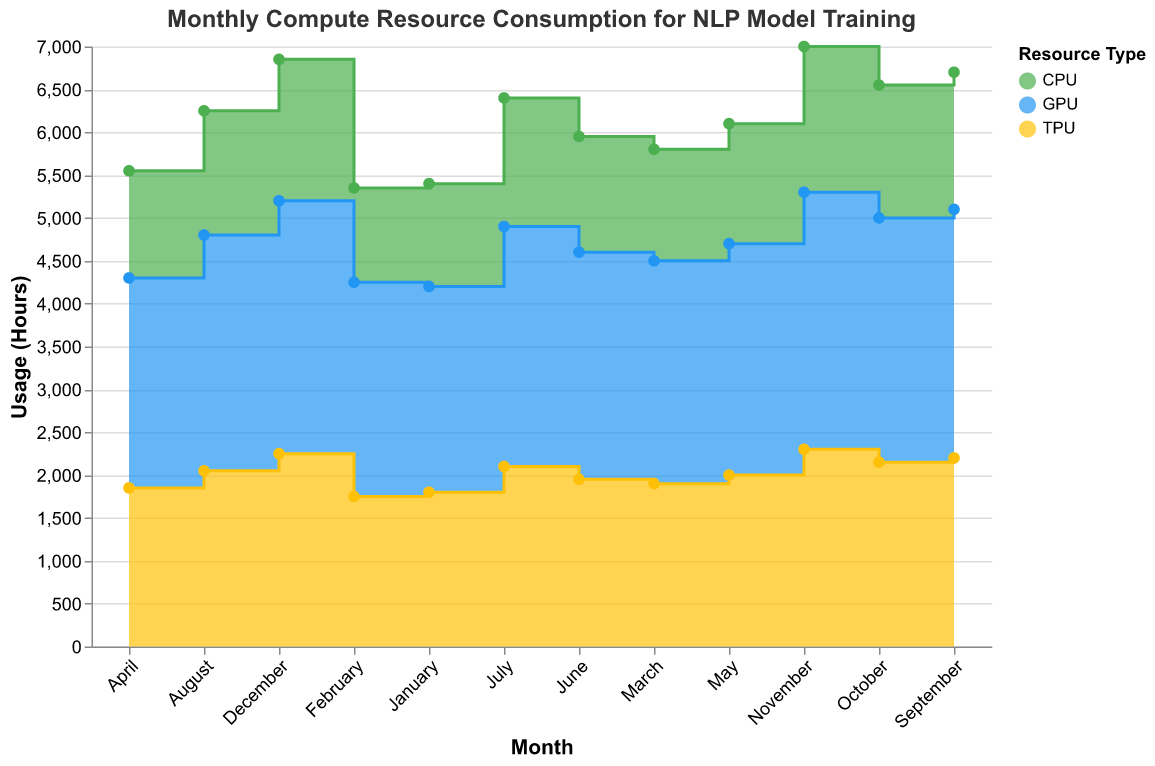What is the title of the chart? The title of the chart is displayed at the top and reads: "Monthly Compute Resource Consumption for NLP Model Training".
Answer: Monthly Compute Resource Consumption for NLP Model Training Which resource type had the highest usage in November? By looking at the November data points, GPU has the highest usage with 3000 hours.
Answer: GPU Which month had the highest total compute resource usage? To find the month with the highest total usage, sum the usage of CPU, GPU, and TPU for each month. November has the highest total compute resource usage: CPU (1700) + GPU (3000) + TPU (2300) = 7000 hours.
Answer: November How does the GPU usage in December compare to the GPU usage in January? GPU usage in December is 2950 hours, whereas GPU usage in January is 2400 hours. Comparing these, December has a higher GPU usage by 550 hours.
Answer: December has 550 hours more What is the average CPU usage over the 12 months? To find the average CPU usage, sum the CPU usage for each month and divide by 12: (1200 + 1100 + 1300 + 1250 + 1400 + 1350 + 1500 + 1450 + 1600 + 1550 + 1700 + 1650) / 12 = 15750 / 12 = 1312.5 hours.
Answer: 1312.5 hours Was there a month when both GPU and TPU usage decreased from the previous month? Compare month-to-month usage for GPU and TPU. From April to May, both GPU (2450 to 2700) and TPU (1850 to 2000) increased. From May to June, both GPU (2700 to 2650) and TPU (2000 to 1950) decreased. Hence, June is the month where both decreased from May.
Answer: June Which resource type showed more consistent monthly usage patterns throughout the year? Consistency can be observed by visually assessing the smoothness of the area chart lines. CPU usage shows relatively less fluctuation compared to GPU and TPU, indicating more consistent monthly usage.
Answer: CPU When did TPU usage surpass GPU usage? By tracking the lines in the step area chart, at no point throughout the year does TPU usage surpass GPU usage; GPU usage is consistently higher than TPU.
Answer: Never What is the combined usage (CPU + GPU + TPU) in July? Sum the CPU, GPU, and TPU usage in July: CPU (1500) + GPU (2800) + TPU (2100) = 6400 hours.
Answer: 6400 hours What is the trend of CPU usage from January to December? CPU usage starts at 1200 hours in January and increases generally over the months, with some minor fluctuations, reaching 1650 hours in December. The overall trend is an upward increase.
Answer: Increasing trend 